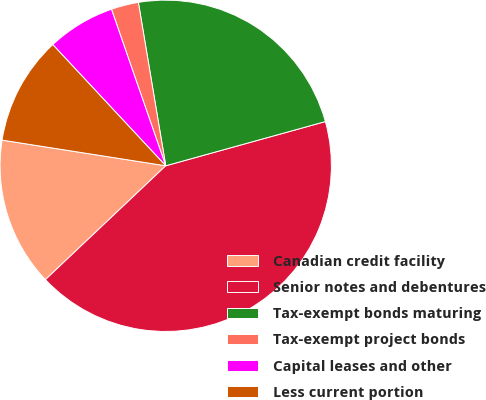Convert chart. <chart><loc_0><loc_0><loc_500><loc_500><pie_chart><fcel>Canadian credit facility<fcel>Senior notes and debentures<fcel>Tax-exempt bonds maturing<fcel>Tax-exempt project bonds<fcel>Capital leases and other<fcel>Less current portion<nl><fcel>14.54%<fcel>42.24%<fcel>23.34%<fcel>2.67%<fcel>6.63%<fcel>10.58%<nl></chart> 